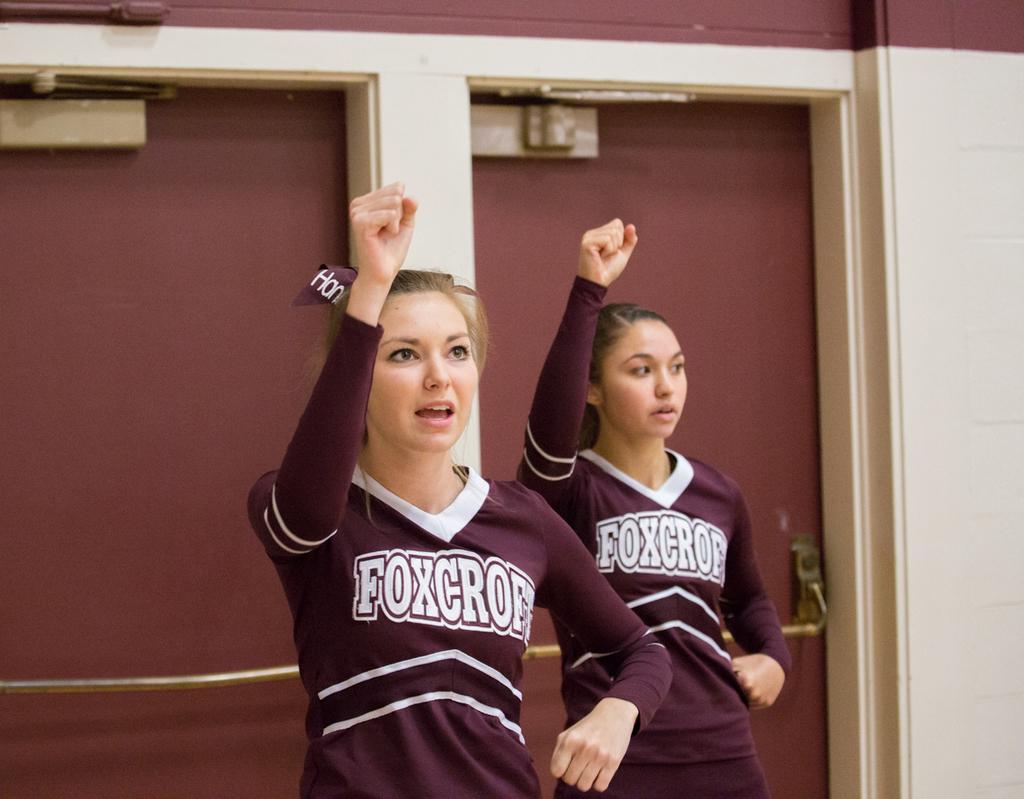What school name is on the front of the girls' uniforms?
Ensure brevity in your answer.  Foxcroft. The school is foxcroft?
Offer a very short reply. Yes. 